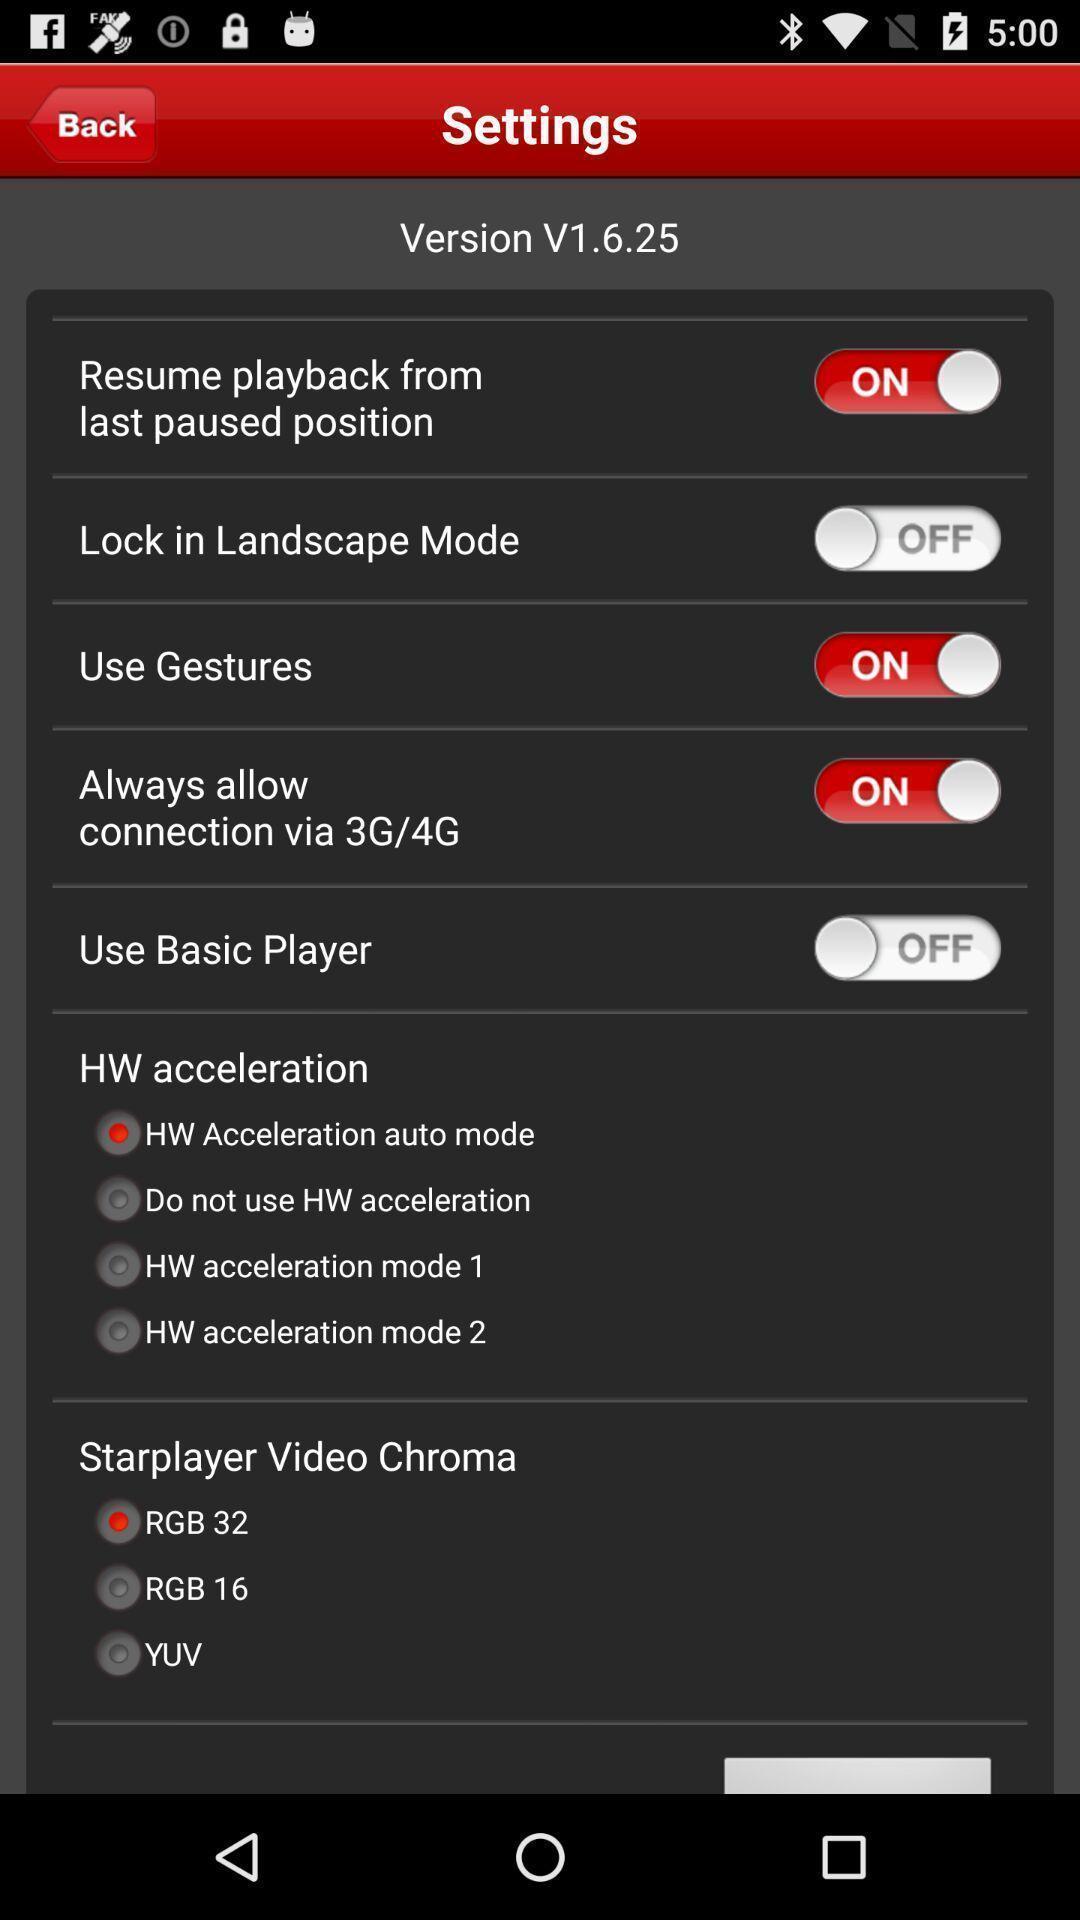Describe the visual elements of this screenshot. Settings page with various options. 